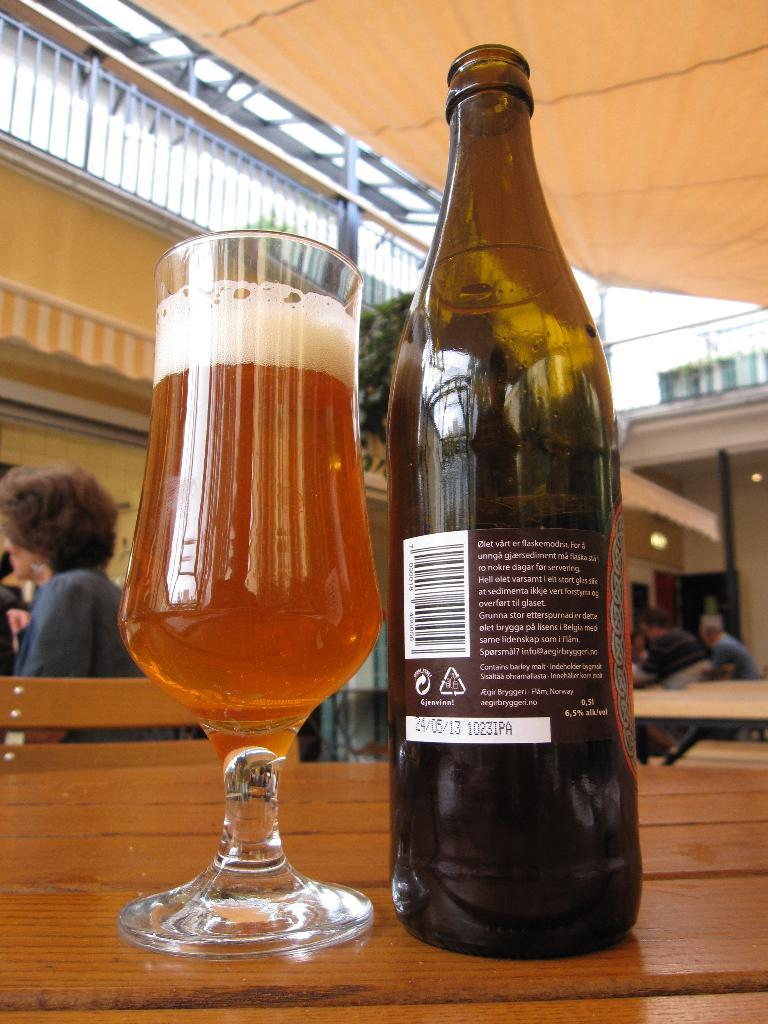<image>
Write a terse but informative summary of the picture. Bottle of alcohol which has the date May 13th on it. 